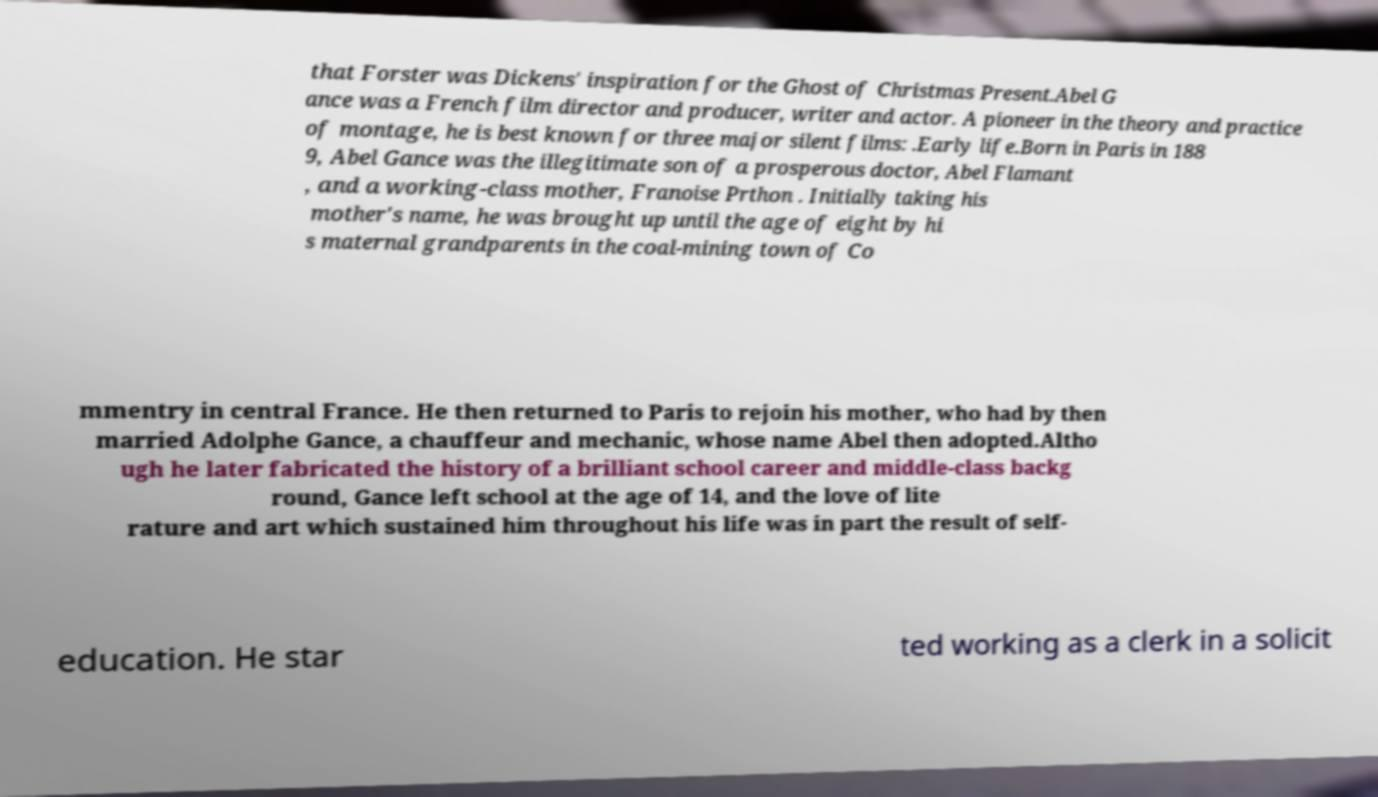Can you accurately transcribe the text from the provided image for me? that Forster was Dickens' inspiration for the Ghost of Christmas Present.Abel G ance was a French film director and producer, writer and actor. A pioneer in the theory and practice of montage, he is best known for three major silent films: .Early life.Born in Paris in 188 9, Abel Gance was the illegitimate son of a prosperous doctor, Abel Flamant , and a working-class mother, Franoise Prthon . Initially taking his mother's name, he was brought up until the age of eight by hi s maternal grandparents in the coal-mining town of Co mmentry in central France. He then returned to Paris to rejoin his mother, who had by then married Adolphe Gance, a chauffeur and mechanic, whose name Abel then adopted.Altho ugh he later fabricated the history of a brilliant school career and middle-class backg round, Gance left school at the age of 14, and the love of lite rature and art which sustained him throughout his life was in part the result of self- education. He star ted working as a clerk in a solicit 